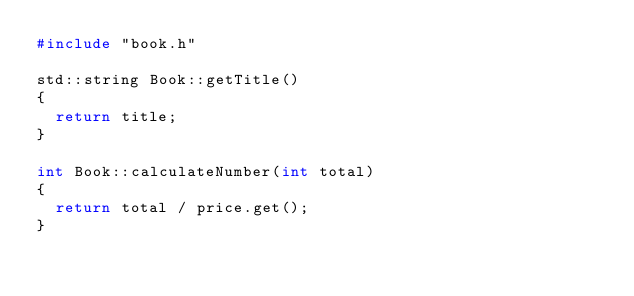Convert code to text. <code><loc_0><loc_0><loc_500><loc_500><_C++_>#include "book.h"

std::string Book::getTitle()
{
  return title;
}

int Book::calculateNumber(int total)
{
  return total / price.get();
}
</code> 